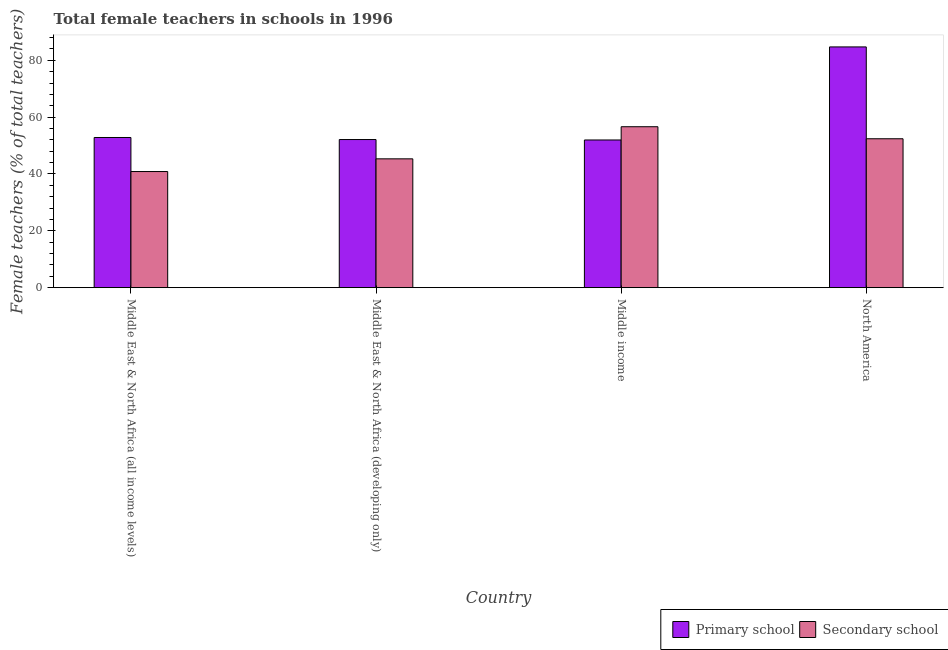How many groups of bars are there?
Keep it short and to the point. 4. How many bars are there on the 2nd tick from the left?
Provide a succinct answer. 2. What is the percentage of female teachers in secondary schools in Middle East & North Africa (all income levels)?
Your answer should be compact. 40.86. Across all countries, what is the maximum percentage of female teachers in primary schools?
Make the answer very short. 84.71. Across all countries, what is the minimum percentage of female teachers in secondary schools?
Offer a terse response. 40.86. In which country was the percentage of female teachers in secondary schools maximum?
Keep it short and to the point. Middle income. In which country was the percentage of female teachers in secondary schools minimum?
Ensure brevity in your answer.  Middle East & North Africa (all income levels). What is the total percentage of female teachers in secondary schools in the graph?
Keep it short and to the point. 195.21. What is the difference between the percentage of female teachers in primary schools in Middle East & North Africa (developing only) and that in Middle income?
Give a very brief answer. 0.15. What is the difference between the percentage of female teachers in primary schools in Middle East & North Africa (developing only) and the percentage of female teachers in secondary schools in Middle East & North Africa (all income levels)?
Ensure brevity in your answer.  11.26. What is the average percentage of female teachers in secondary schools per country?
Offer a very short reply. 48.8. What is the difference between the percentage of female teachers in primary schools and percentage of female teachers in secondary schools in Middle income?
Make the answer very short. -4.66. What is the ratio of the percentage of female teachers in secondary schools in Middle East & North Africa (all income levels) to that in Middle income?
Offer a very short reply. 0.72. Is the percentage of female teachers in primary schools in Middle East & North Africa (all income levels) less than that in North America?
Offer a very short reply. Yes. Is the difference between the percentage of female teachers in secondary schools in Middle income and North America greater than the difference between the percentage of female teachers in primary schools in Middle income and North America?
Make the answer very short. Yes. What is the difference between the highest and the second highest percentage of female teachers in secondary schools?
Provide a succinct answer. 4.23. What is the difference between the highest and the lowest percentage of female teachers in primary schools?
Make the answer very short. 32.74. In how many countries, is the percentage of female teachers in primary schools greater than the average percentage of female teachers in primary schools taken over all countries?
Make the answer very short. 1. Is the sum of the percentage of female teachers in secondary schools in Middle East & North Africa (all income levels) and Middle income greater than the maximum percentage of female teachers in primary schools across all countries?
Offer a terse response. Yes. What does the 2nd bar from the left in Middle East & North Africa (developing only) represents?
Keep it short and to the point. Secondary school. What does the 1st bar from the right in North America represents?
Provide a short and direct response. Secondary school. Are all the bars in the graph horizontal?
Your answer should be compact. No. What is the difference between two consecutive major ticks on the Y-axis?
Give a very brief answer. 20. Does the graph contain any zero values?
Offer a very short reply. No. Where does the legend appear in the graph?
Ensure brevity in your answer.  Bottom right. How many legend labels are there?
Provide a succinct answer. 2. What is the title of the graph?
Your answer should be compact. Total female teachers in schools in 1996. What is the label or title of the X-axis?
Keep it short and to the point. Country. What is the label or title of the Y-axis?
Keep it short and to the point. Female teachers (% of total teachers). What is the Female teachers (% of total teachers) in Primary school in Middle East & North Africa (all income levels)?
Your response must be concise. 52.84. What is the Female teachers (% of total teachers) in Secondary school in Middle East & North Africa (all income levels)?
Offer a terse response. 40.86. What is the Female teachers (% of total teachers) of Primary school in Middle East & North Africa (developing only)?
Your answer should be very brief. 52.12. What is the Female teachers (% of total teachers) in Secondary school in Middle East & North Africa (developing only)?
Keep it short and to the point. 45.33. What is the Female teachers (% of total teachers) in Primary school in Middle income?
Provide a succinct answer. 51.97. What is the Female teachers (% of total teachers) of Secondary school in Middle income?
Your answer should be compact. 56.63. What is the Female teachers (% of total teachers) of Primary school in North America?
Provide a short and direct response. 84.71. What is the Female teachers (% of total teachers) in Secondary school in North America?
Make the answer very short. 52.39. Across all countries, what is the maximum Female teachers (% of total teachers) of Primary school?
Make the answer very short. 84.71. Across all countries, what is the maximum Female teachers (% of total teachers) of Secondary school?
Offer a very short reply. 56.63. Across all countries, what is the minimum Female teachers (% of total teachers) in Primary school?
Offer a terse response. 51.97. Across all countries, what is the minimum Female teachers (% of total teachers) of Secondary school?
Offer a very short reply. 40.86. What is the total Female teachers (% of total teachers) of Primary school in the graph?
Your answer should be very brief. 241.63. What is the total Female teachers (% of total teachers) in Secondary school in the graph?
Offer a very short reply. 195.21. What is the difference between the Female teachers (% of total teachers) of Primary school in Middle East & North Africa (all income levels) and that in Middle East & North Africa (developing only)?
Keep it short and to the point. 0.72. What is the difference between the Female teachers (% of total teachers) in Secondary school in Middle East & North Africa (all income levels) and that in Middle East & North Africa (developing only)?
Offer a very short reply. -4.47. What is the difference between the Female teachers (% of total teachers) of Primary school in Middle East & North Africa (all income levels) and that in Middle income?
Keep it short and to the point. 0.87. What is the difference between the Female teachers (% of total teachers) in Secondary school in Middle East & North Africa (all income levels) and that in Middle income?
Keep it short and to the point. -15.77. What is the difference between the Female teachers (% of total teachers) in Primary school in Middle East & North Africa (all income levels) and that in North America?
Provide a succinct answer. -31.87. What is the difference between the Female teachers (% of total teachers) in Secondary school in Middle East & North Africa (all income levels) and that in North America?
Make the answer very short. -11.53. What is the difference between the Female teachers (% of total teachers) in Primary school in Middle East & North Africa (developing only) and that in Middle income?
Your answer should be compact. 0.15. What is the difference between the Female teachers (% of total teachers) in Secondary school in Middle East & North Africa (developing only) and that in Middle income?
Provide a succinct answer. -11.29. What is the difference between the Female teachers (% of total teachers) in Primary school in Middle East & North Africa (developing only) and that in North America?
Give a very brief answer. -32.59. What is the difference between the Female teachers (% of total teachers) of Secondary school in Middle East & North Africa (developing only) and that in North America?
Your answer should be very brief. -7.06. What is the difference between the Female teachers (% of total teachers) of Primary school in Middle income and that in North America?
Keep it short and to the point. -32.74. What is the difference between the Female teachers (% of total teachers) of Secondary school in Middle income and that in North America?
Offer a very short reply. 4.23. What is the difference between the Female teachers (% of total teachers) in Primary school in Middle East & North Africa (all income levels) and the Female teachers (% of total teachers) in Secondary school in Middle East & North Africa (developing only)?
Offer a very short reply. 7.51. What is the difference between the Female teachers (% of total teachers) in Primary school in Middle East & North Africa (all income levels) and the Female teachers (% of total teachers) in Secondary school in Middle income?
Provide a short and direct response. -3.79. What is the difference between the Female teachers (% of total teachers) in Primary school in Middle East & North Africa (all income levels) and the Female teachers (% of total teachers) in Secondary school in North America?
Your response must be concise. 0.44. What is the difference between the Female teachers (% of total teachers) in Primary school in Middle East & North Africa (developing only) and the Female teachers (% of total teachers) in Secondary school in Middle income?
Offer a very short reply. -4.51. What is the difference between the Female teachers (% of total teachers) in Primary school in Middle East & North Africa (developing only) and the Female teachers (% of total teachers) in Secondary school in North America?
Your answer should be compact. -0.28. What is the difference between the Female teachers (% of total teachers) of Primary school in Middle income and the Female teachers (% of total teachers) of Secondary school in North America?
Keep it short and to the point. -0.43. What is the average Female teachers (% of total teachers) in Primary school per country?
Give a very brief answer. 60.41. What is the average Female teachers (% of total teachers) in Secondary school per country?
Provide a succinct answer. 48.8. What is the difference between the Female teachers (% of total teachers) in Primary school and Female teachers (% of total teachers) in Secondary school in Middle East & North Africa (all income levels)?
Give a very brief answer. 11.98. What is the difference between the Female teachers (% of total teachers) in Primary school and Female teachers (% of total teachers) in Secondary school in Middle East & North Africa (developing only)?
Provide a short and direct response. 6.79. What is the difference between the Female teachers (% of total teachers) of Primary school and Female teachers (% of total teachers) of Secondary school in Middle income?
Your answer should be compact. -4.66. What is the difference between the Female teachers (% of total teachers) in Primary school and Female teachers (% of total teachers) in Secondary school in North America?
Keep it short and to the point. 32.32. What is the ratio of the Female teachers (% of total teachers) of Primary school in Middle East & North Africa (all income levels) to that in Middle East & North Africa (developing only)?
Make the answer very short. 1.01. What is the ratio of the Female teachers (% of total teachers) in Secondary school in Middle East & North Africa (all income levels) to that in Middle East & North Africa (developing only)?
Keep it short and to the point. 0.9. What is the ratio of the Female teachers (% of total teachers) of Primary school in Middle East & North Africa (all income levels) to that in Middle income?
Make the answer very short. 1.02. What is the ratio of the Female teachers (% of total teachers) of Secondary school in Middle East & North Africa (all income levels) to that in Middle income?
Provide a short and direct response. 0.72. What is the ratio of the Female teachers (% of total teachers) in Primary school in Middle East & North Africa (all income levels) to that in North America?
Your response must be concise. 0.62. What is the ratio of the Female teachers (% of total teachers) in Secondary school in Middle East & North Africa (all income levels) to that in North America?
Your answer should be very brief. 0.78. What is the ratio of the Female teachers (% of total teachers) of Primary school in Middle East & North Africa (developing only) to that in Middle income?
Offer a terse response. 1. What is the ratio of the Female teachers (% of total teachers) of Secondary school in Middle East & North Africa (developing only) to that in Middle income?
Offer a very short reply. 0.8. What is the ratio of the Female teachers (% of total teachers) in Primary school in Middle East & North Africa (developing only) to that in North America?
Ensure brevity in your answer.  0.62. What is the ratio of the Female teachers (% of total teachers) of Secondary school in Middle East & North Africa (developing only) to that in North America?
Offer a terse response. 0.87. What is the ratio of the Female teachers (% of total teachers) in Primary school in Middle income to that in North America?
Your answer should be compact. 0.61. What is the ratio of the Female teachers (% of total teachers) of Secondary school in Middle income to that in North America?
Offer a very short reply. 1.08. What is the difference between the highest and the second highest Female teachers (% of total teachers) in Primary school?
Your answer should be compact. 31.87. What is the difference between the highest and the second highest Female teachers (% of total teachers) of Secondary school?
Your response must be concise. 4.23. What is the difference between the highest and the lowest Female teachers (% of total teachers) of Primary school?
Ensure brevity in your answer.  32.74. What is the difference between the highest and the lowest Female teachers (% of total teachers) of Secondary school?
Your response must be concise. 15.77. 